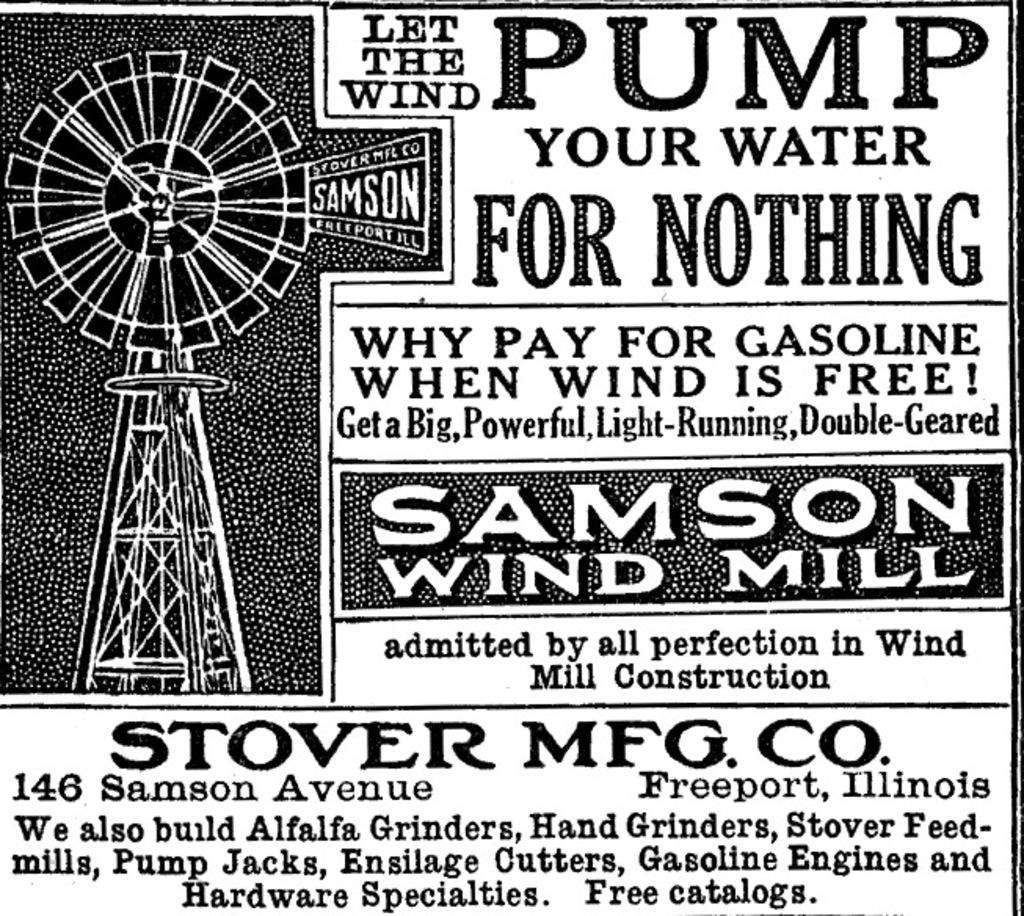<image>
Write a terse but informative summary of the picture. An old black and white advertisement for Samson Wind Mill company. 